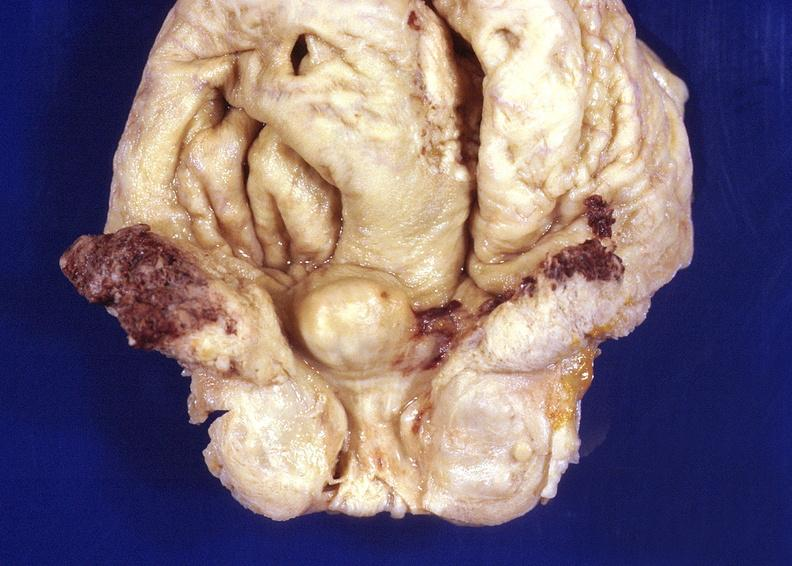does spina bifida show prostatic hyperplasia?
Answer the question using a single word or phrase. No 